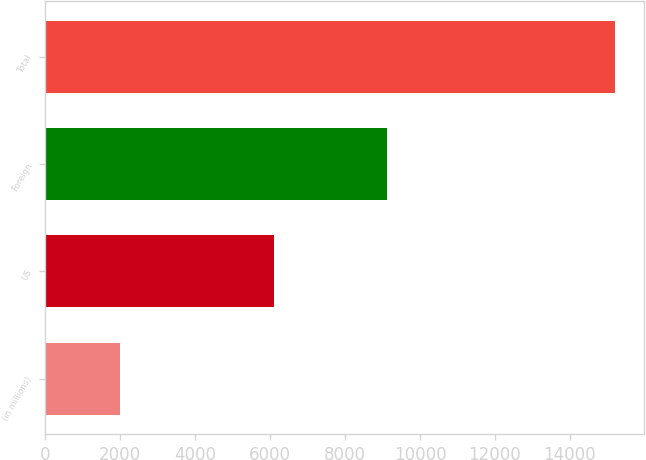Convert chart to OTSL. <chart><loc_0><loc_0><loc_500><loc_500><bar_chart><fcel>(in millions)<fcel>US<fcel>Foreign<fcel>Total<nl><fcel>2005<fcel>6103<fcel>9110<fcel>15213<nl></chart> 